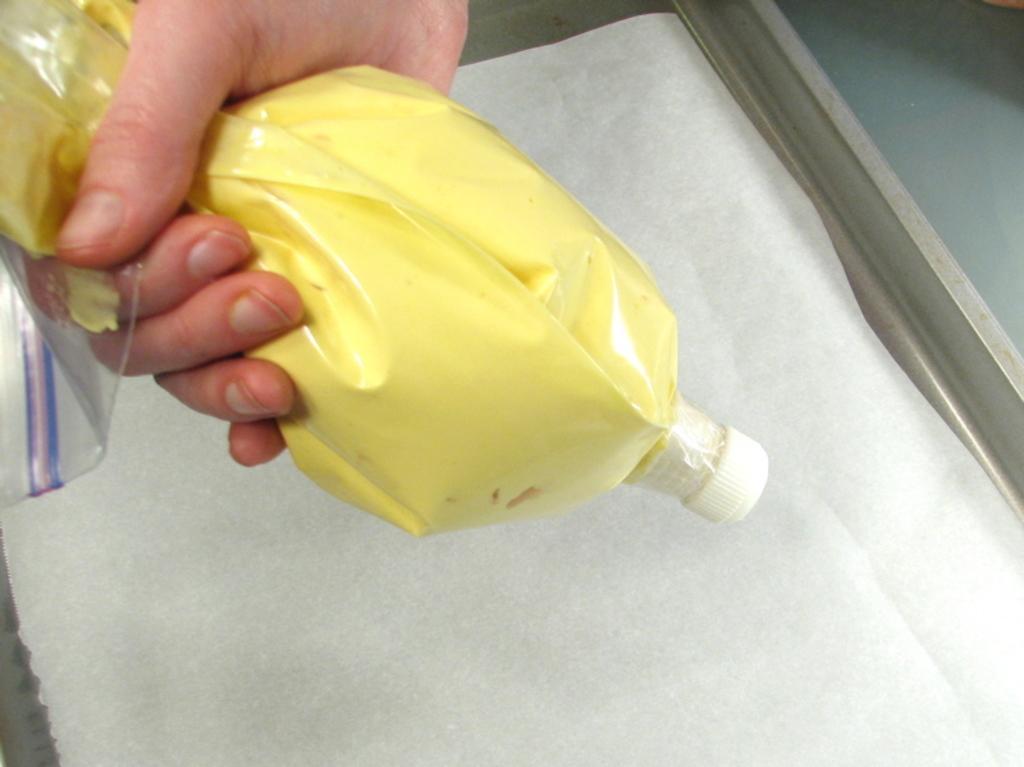Please provide a concise description of this image. In this picture we can see a person holding a bottle and in the background we can see a white color sheet and window. 